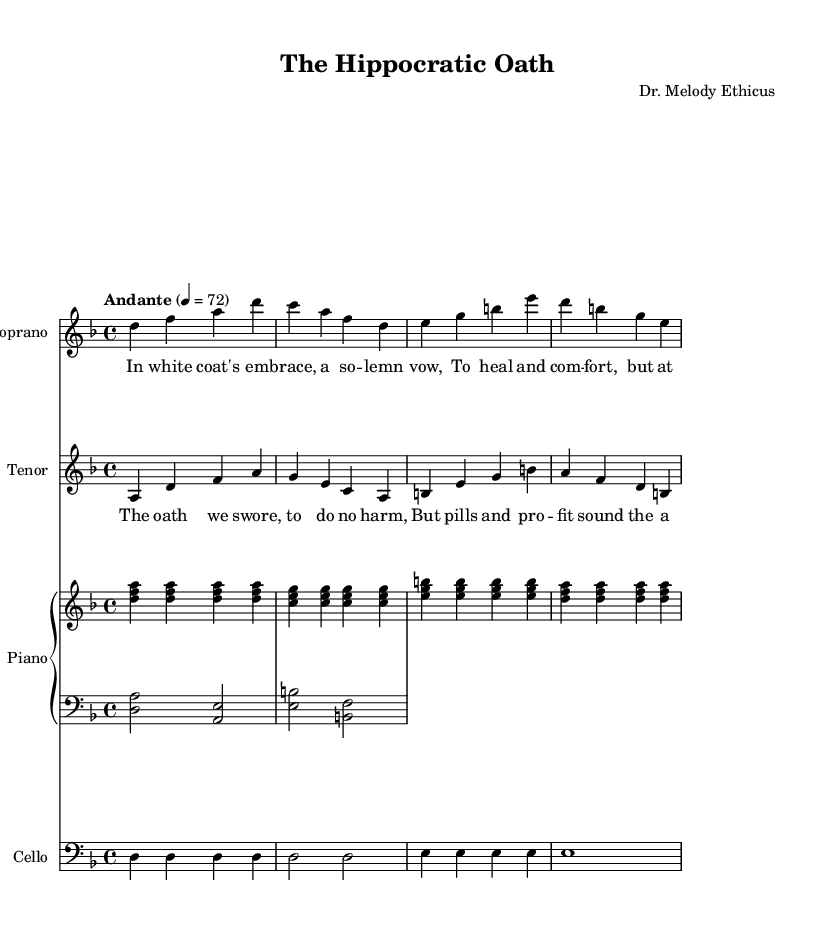What is the key signature of this music? The key signature is indicated at the beginning of the staff. The absence of any sharps or flats indicates it is in D minor, which has one flat (B flat) indicated in the key signature.
Answer: D minor What is the time signature of this music? The time signature is shown at the beginning of the staff. The notation "4/4" indicates a common time signature, meaning there are four beats in each measure and the quarter note receives one beat.
Answer: 4/4 What is the tempo marking of this piece? The tempo marking is provided above the staff and reads "Andante 4 = 72." This indicates a moderate pace of 72 beats per minute.
Answer: Andante 4 = 72 How many measures are in the soprano part? The soprano part is indicated by a series of vertical lines called bar lines, which separate measures. Counting these, there are a total of four measures in the soprano part.
Answer: 4 Who is the composer of this piece? The composer's name is listed in the header section of the sheet music, which states "Dr. Melody Ethicus" as the composer.
Answer: Dr. Melody Ethicus What themes do the lyrics in the verse suggest? The lyrics of the verse mention a "solemn vow" to heal and comfort, while questioning the cost associated with this duty. This points to ethical dilemmas in medicine, aligning with the opera's theme of medical ethics.
Answer: Ethical dilemmas What is the role of the cello in this piece? The cello plays a supportive musical line that complements both the soprano and tenor voices. It provides harmonic depth and underscores the themes of the piece with its bass line.
Answer: Supportive harmonic line 